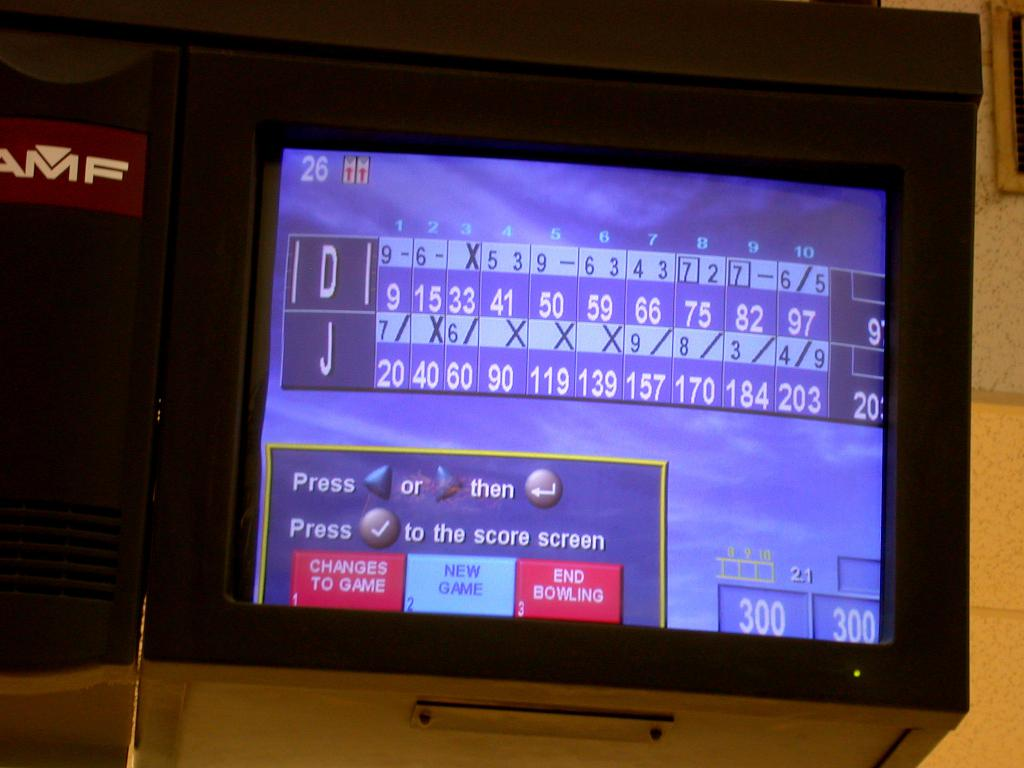Can you tell what might be the highest possible score in this game, based on the scoreboard? The scoreboard indicates a maximum score of 300, commonly known as a perfect score in bowling, which is achieved by bowling 12 consecutive strikes. 